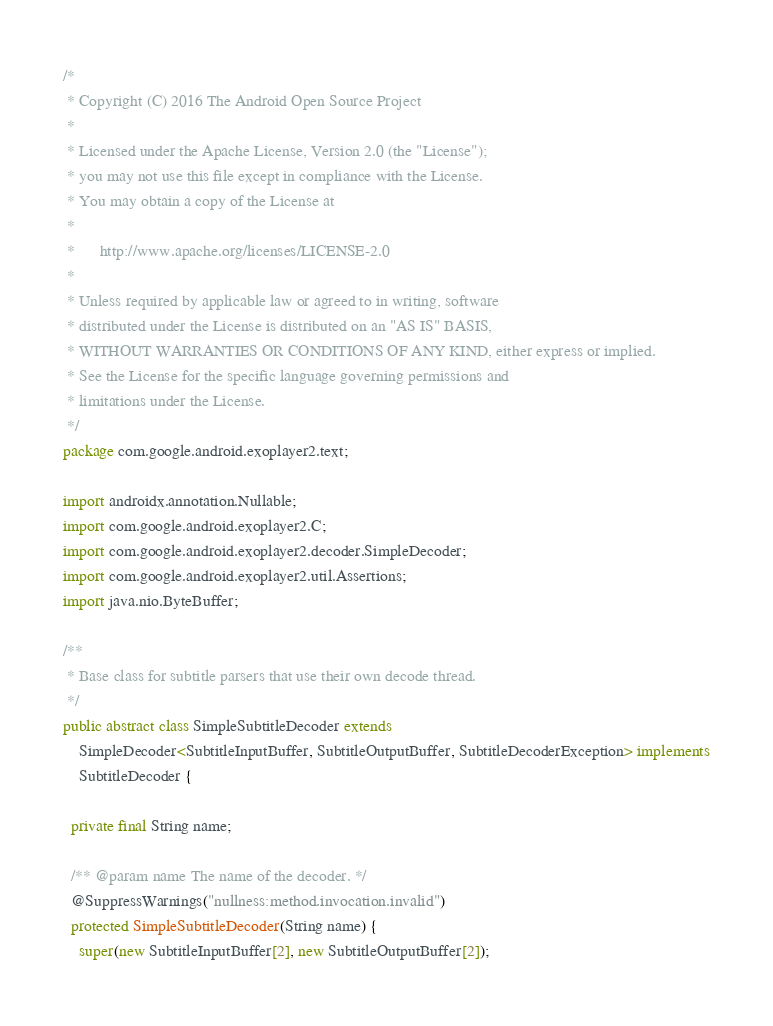<code> <loc_0><loc_0><loc_500><loc_500><_Java_>/*
 * Copyright (C) 2016 The Android Open Source Project
 *
 * Licensed under the Apache License, Version 2.0 (the "License");
 * you may not use this file except in compliance with the License.
 * You may obtain a copy of the License at
 *
 *      http://www.apache.org/licenses/LICENSE-2.0
 *
 * Unless required by applicable law or agreed to in writing, software
 * distributed under the License is distributed on an "AS IS" BASIS,
 * WITHOUT WARRANTIES OR CONDITIONS OF ANY KIND, either express or implied.
 * See the License for the specific language governing permissions and
 * limitations under the License.
 */
package com.google.android.exoplayer2.text;

import androidx.annotation.Nullable;
import com.google.android.exoplayer2.C;
import com.google.android.exoplayer2.decoder.SimpleDecoder;
import com.google.android.exoplayer2.util.Assertions;
import java.nio.ByteBuffer;

/**
 * Base class for subtitle parsers that use their own decode thread.
 */
public abstract class SimpleSubtitleDecoder extends
    SimpleDecoder<SubtitleInputBuffer, SubtitleOutputBuffer, SubtitleDecoderException> implements
    SubtitleDecoder {

  private final String name;

  /** @param name The name of the decoder. */
  @SuppressWarnings("nullness:method.invocation.invalid")
  protected SimpleSubtitleDecoder(String name) {
    super(new SubtitleInputBuffer[2], new SubtitleOutputBuffer[2]);</code> 